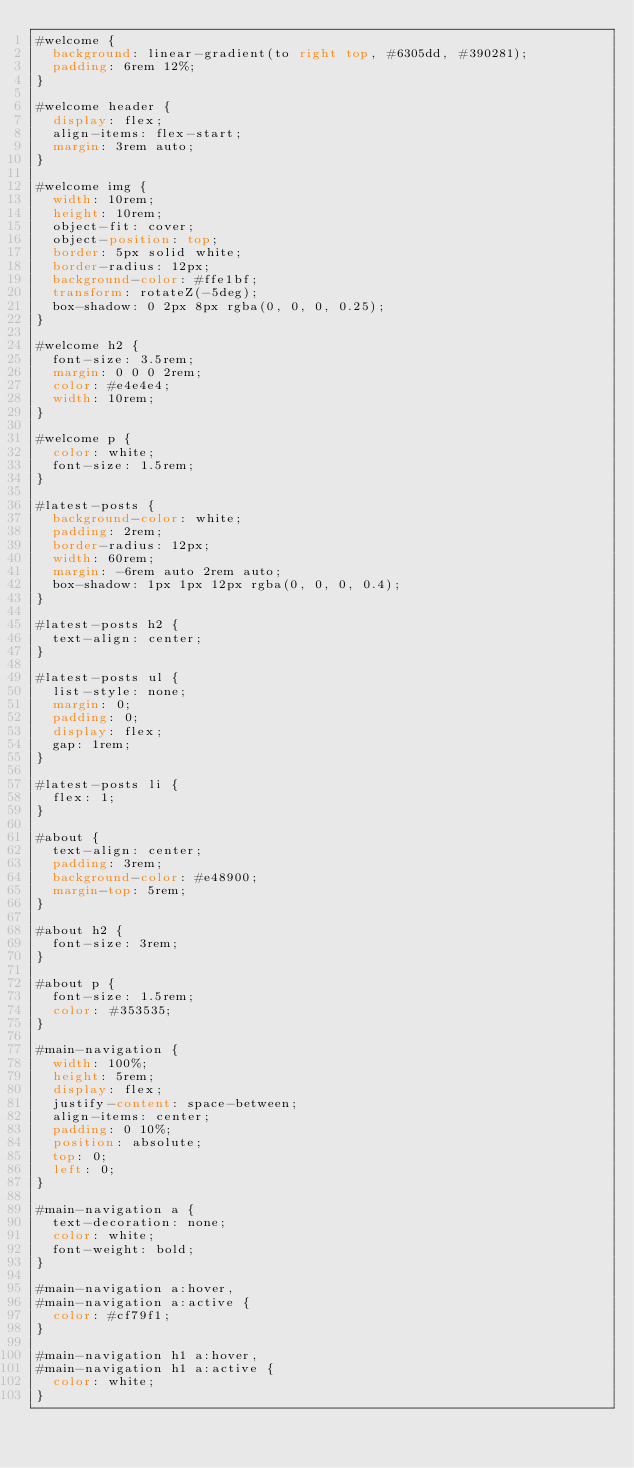Convert code to text. <code><loc_0><loc_0><loc_500><loc_500><_CSS_>#welcome {
  background: linear-gradient(to right top, #6305dd, #390281);
  padding: 6rem 12%;
}

#welcome header {
  display: flex;
  align-items: flex-start;
  margin: 3rem auto;
}

#welcome img {
  width: 10rem;
  height: 10rem;
  object-fit: cover;
  object-position: top;
  border: 5px solid white;
  border-radius: 12px;
  background-color: #ffe1bf;
  transform: rotateZ(-5deg);
  box-shadow: 0 2px 8px rgba(0, 0, 0, 0.25);
}

#welcome h2 {
  font-size: 3.5rem;
  margin: 0 0 0 2rem;
  color: #e4e4e4;
  width: 10rem;
}

#welcome p {
  color: white;
  font-size: 1.5rem;
}

#latest-posts {
  background-color: white;
  padding: 2rem;
  border-radius: 12px;
  width: 60rem;
  margin: -6rem auto 2rem auto;
  box-shadow: 1px 1px 12px rgba(0, 0, 0, 0.4);
}

#latest-posts h2 {
  text-align: center;
}

#latest-posts ul {
  list-style: none;
  margin: 0;
  padding: 0;
  display: flex;
  gap: 1rem;
}

#latest-posts li {
  flex: 1;
}

#about {
  text-align: center;
  padding: 3rem;
  background-color: #e48900;
  margin-top: 5rem;
}

#about h2 {
  font-size: 3rem;
}

#about p {
  font-size: 1.5rem;
  color: #353535;
}

#main-navigation {
  width: 100%;
  height: 5rem;
  display: flex;
  justify-content: space-between;
  align-items: center;
  padding: 0 10%;
  position: absolute;
  top: 0;
  left: 0;
}

#main-navigation a {
  text-decoration: none;
  color: white;
  font-weight: bold;
}

#main-navigation a:hover,
#main-navigation a:active {
  color: #cf79f1;
}

#main-navigation h1 a:hover,
#main-navigation h1 a:active {
  color: white;
}
</code> 